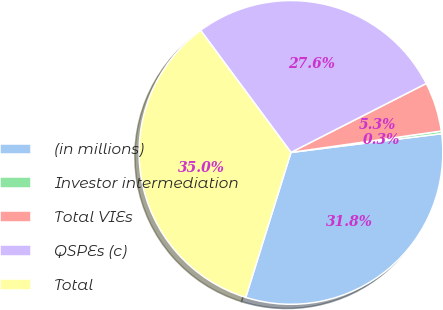<chart> <loc_0><loc_0><loc_500><loc_500><pie_chart><fcel>(in millions)<fcel>Investor intermediation<fcel>Total VIEs<fcel>QSPEs (c)<fcel>Total<nl><fcel>31.78%<fcel>0.28%<fcel>5.25%<fcel>27.64%<fcel>35.04%<nl></chart> 